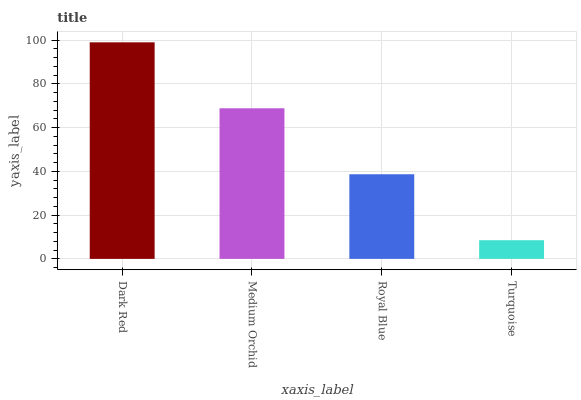Is Turquoise the minimum?
Answer yes or no. Yes. Is Dark Red the maximum?
Answer yes or no. Yes. Is Medium Orchid the minimum?
Answer yes or no. No. Is Medium Orchid the maximum?
Answer yes or no. No. Is Dark Red greater than Medium Orchid?
Answer yes or no. Yes. Is Medium Orchid less than Dark Red?
Answer yes or no. Yes. Is Medium Orchid greater than Dark Red?
Answer yes or no. No. Is Dark Red less than Medium Orchid?
Answer yes or no. No. Is Medium Orchid the high median?
Answer yes or no. Yes. Is Royal Blue the low median?
Answer yes or no. Yes. Is Dark Red the high median?
Answer yes or no. No. Is Turquoise the low median?
Answer yes or no. No. 